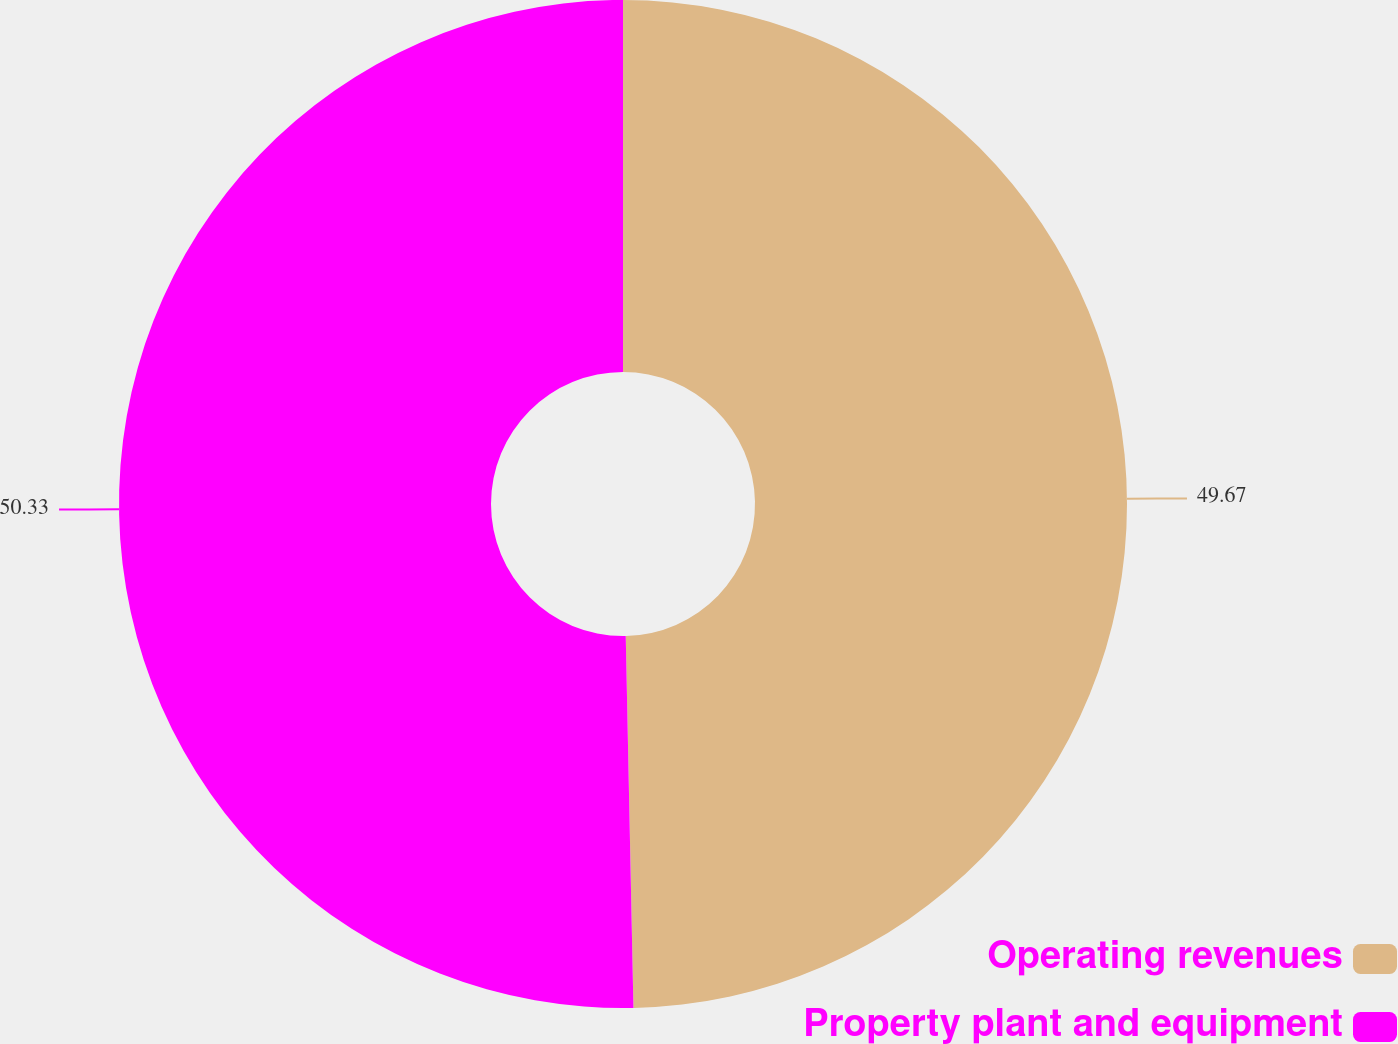Convert chart. <chart><loc_0><loc_0><loc_500><loc_500><pie_chart><fcel>Operating revenues<fcel>Property plant and equipment<nl><fcel>49.67%<fcel>50.33%<nl></chart> 